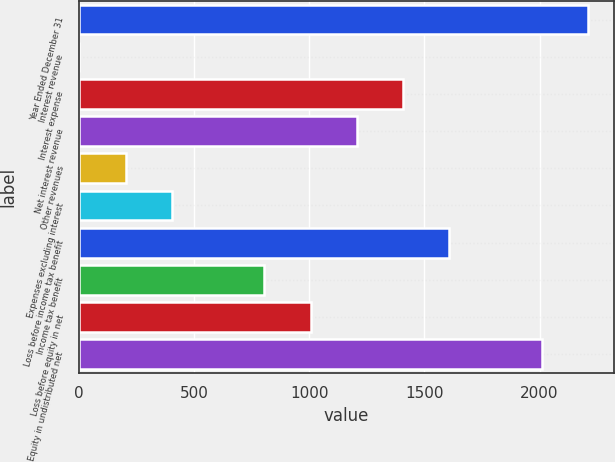Convert chart to OTSL. <chart><loc_0><loc_0><loc_500><loc_500><bar_chart><fcel>Year Ended December 31<fcel>Interest revenue<fcel>Interest expense<fcel>Net interest revenue<fcel>Other revenues<fcel>Expenses excluding interest<fcel>Loss before income tax benefit<fcel>Income tax benefit<fcel>Loss before equity in net<fcel>Equity in undistributed net<nl><fcel>2210.7<fcel>3<fcel>1407.9<fcel>1207.2<fcel>203.7<fcel>404.4<fcel>1608.6<fcel>805.8<fcel>1006.5<fcel>2010<nl></chart> 